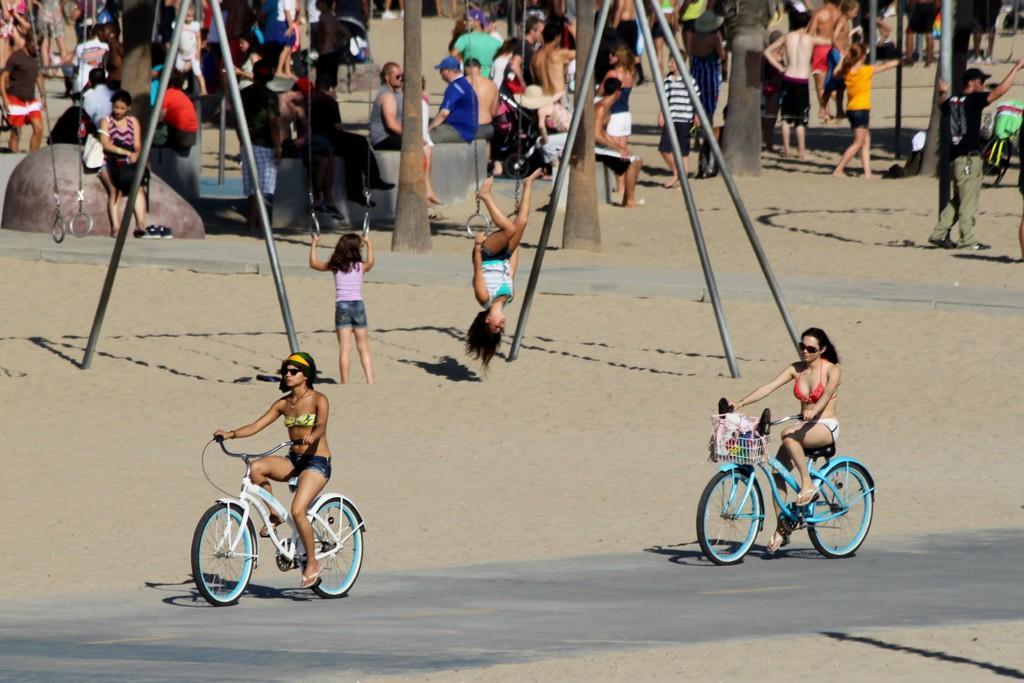Describe this image in one or two sentences. In this picture there are two women riding a bicycles on the road and there are some children playing in the sand with hangings. In the background there are some people sitting and some of them were standing. 